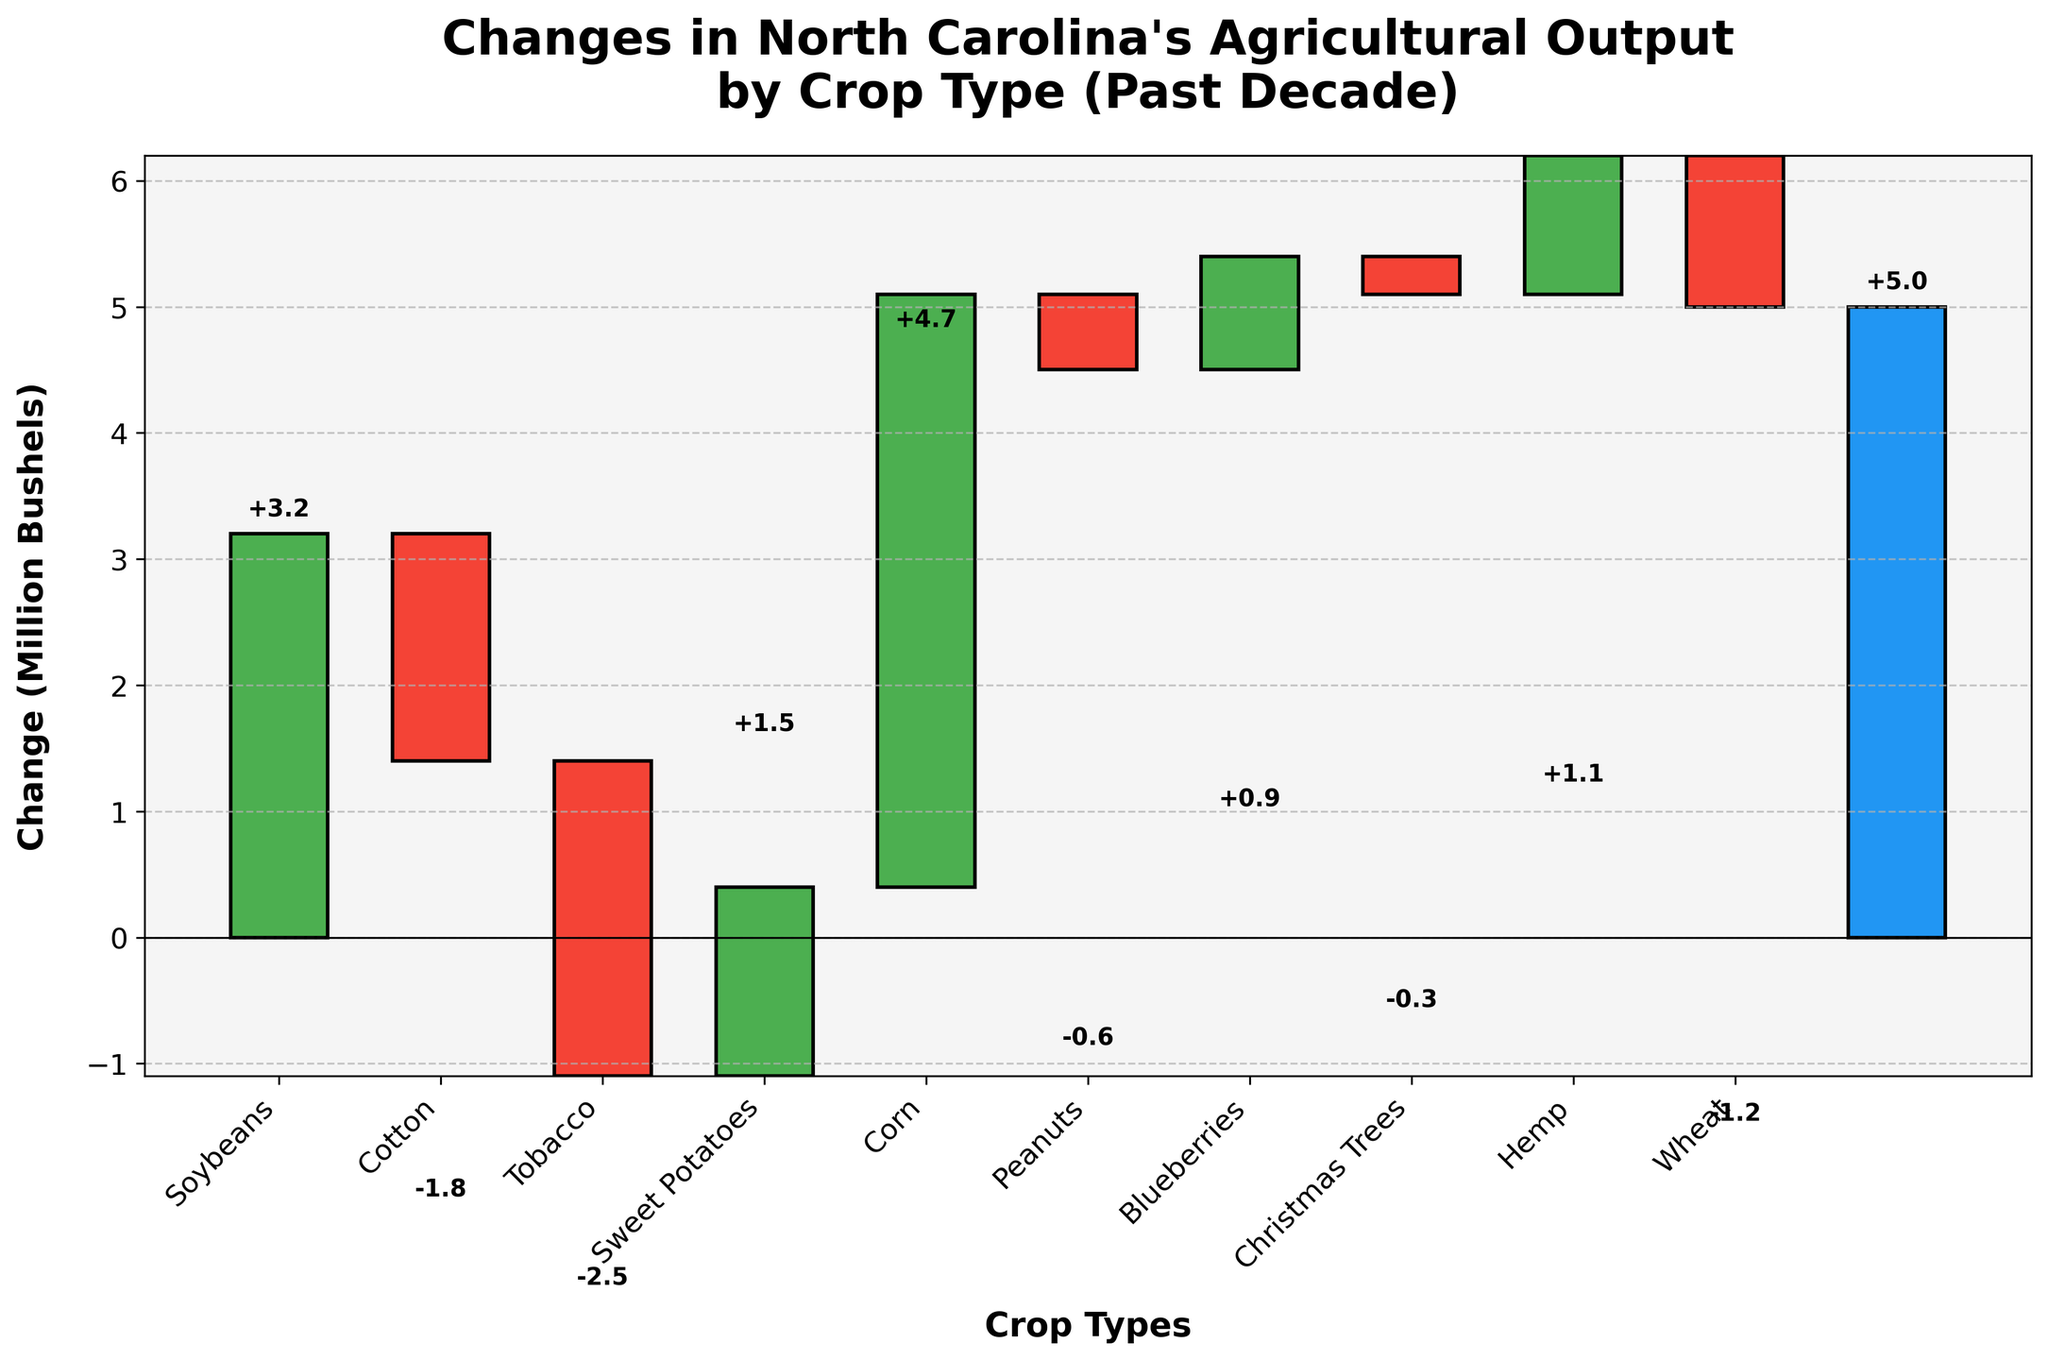What's the title of the figure? The title of the figure is found at the top and it provides an overview of what the chart represents. In this case, it gives a summary of the agricultural changes by crop type over the past decade.
Answer: "Changes in North Carolina's Agricultural Output by Crop Type (Past Decade)" How many crop types experienced a negative change in output? Count the number of crops that have bars going downwards (colored in red). This indicates a negative change in output.
Answer: 5 What is the total net change in agricultural output? The net change is represented by the last bar labeled "Net Change" in the chart. Summing up all changes listed in the data provides the total net change.
Answer: +5 million bushels Which crop experienced the largest positive change in output? To find the largest positive change, identify the tallest green bar in the figure.
Answer: Corn How much did the output of Tobacco change? Locate the bar corresponding to Tobacco and read off the value, which shows the change in output.
Answer: -2.5 million bushels How do the changes in Corn and Soybeans outputs compare? Look at both the bars for Corn and Soybeans, then compare their heights and the values. Corn increased by more than Soybeans.
Answer: Corn increased by 4.7 million bushels and Soybeans by 3.2 million bushels What is the combined change in output for Sweet Potatoes and Peanuts? Add the values for Sweet Potatoes and Peanuts together from their respective bars.
Answer: 1.5 + (-0.6) = 0.9 million bushels Which crop has the smallest positive change in output? Identify the shortest green bar which represents the smallest positive change among the listed crops.
Answer: Blueberries For which crop types did the output decrease by more than 1 million bushels? Check the crops with red bars longer than 1 million bushels decreased, looking at the values listed.
Answer: Cotton, Tobacco, and Wheat What is the cumulative output change for crops with negative changes? Sum the negative values from all the crops that experienced a decrease in output.
Answer: -1.8 - 2.5 - 0.6 - 0.3 - 1.2 = -6.4 million bushels 